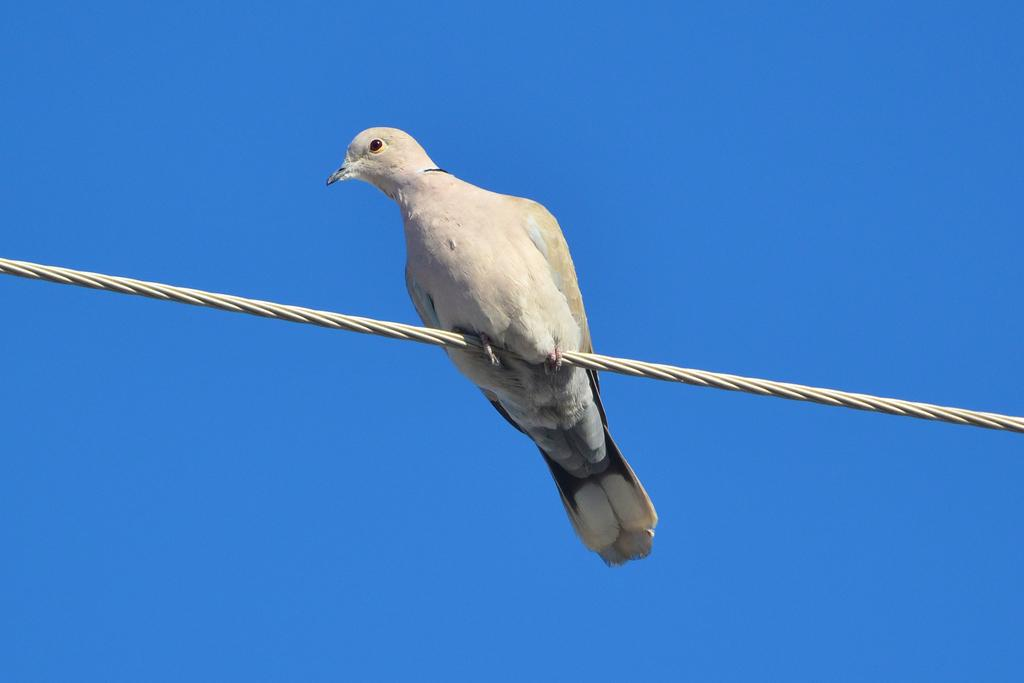What type of animal is present in the image? There is a bird in the image. Where is the bird located? The bird is on a cable. What can be seen in the background of the image? The sky is visible in the background of the image. How much wealth does the bird possess in the image? There is no indication of wealth in the image, as it features a bird on a cable with a visible sky background. 